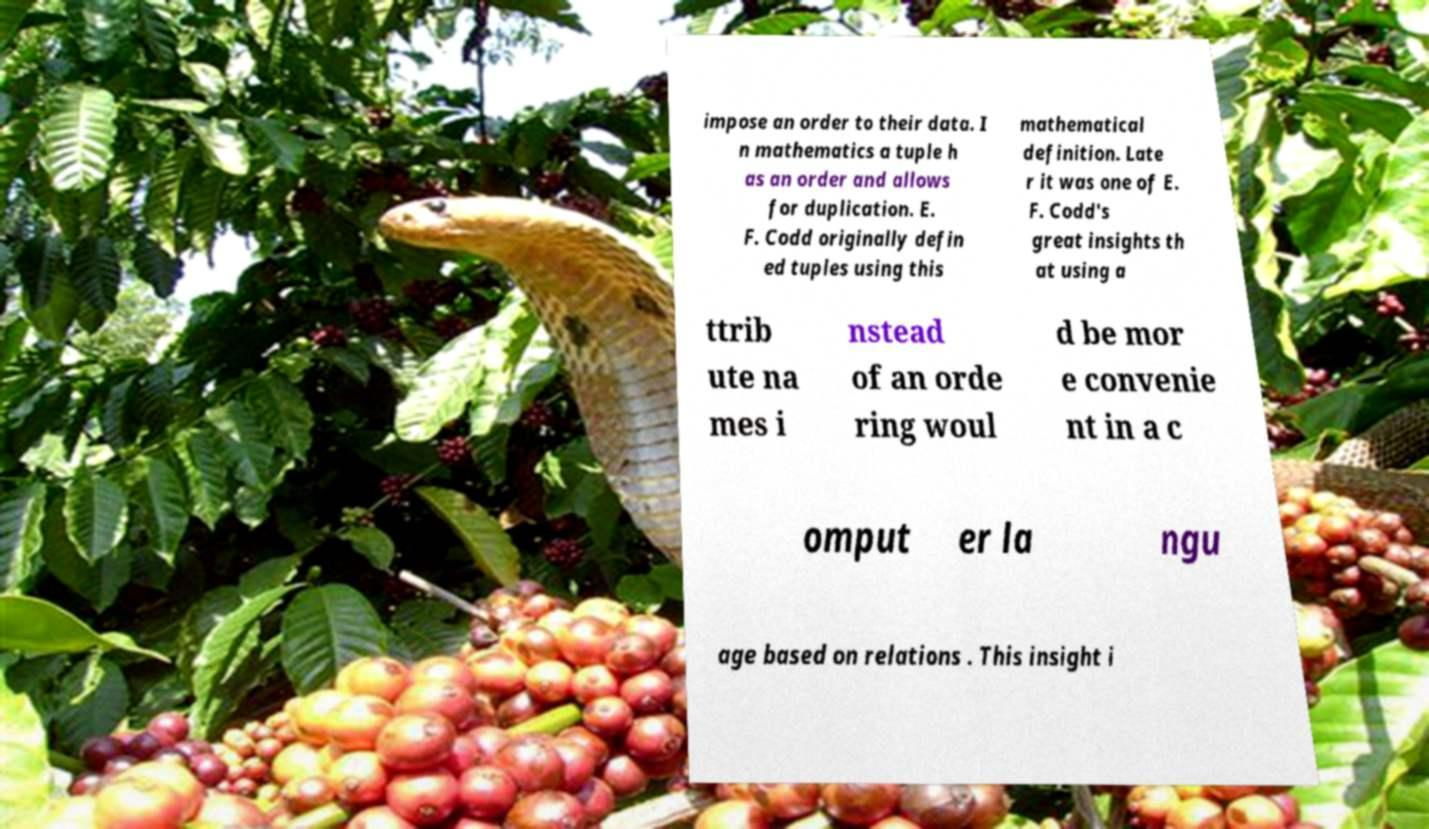For documentation purposes, I need the text within this image transcribed. Could you provide that? impose an order to their data. I n mathematics a tuple h as an order and allows for duplication. E. F. Codd originally defin ed tuples using this mathematical definition. Late r it was one of E. F. Codd's great insights th at using a ttrib ute na mes i nstead of an orde ring woul d be mor e convenie nt in a c omput er la ngu age based on relations . This insight i 